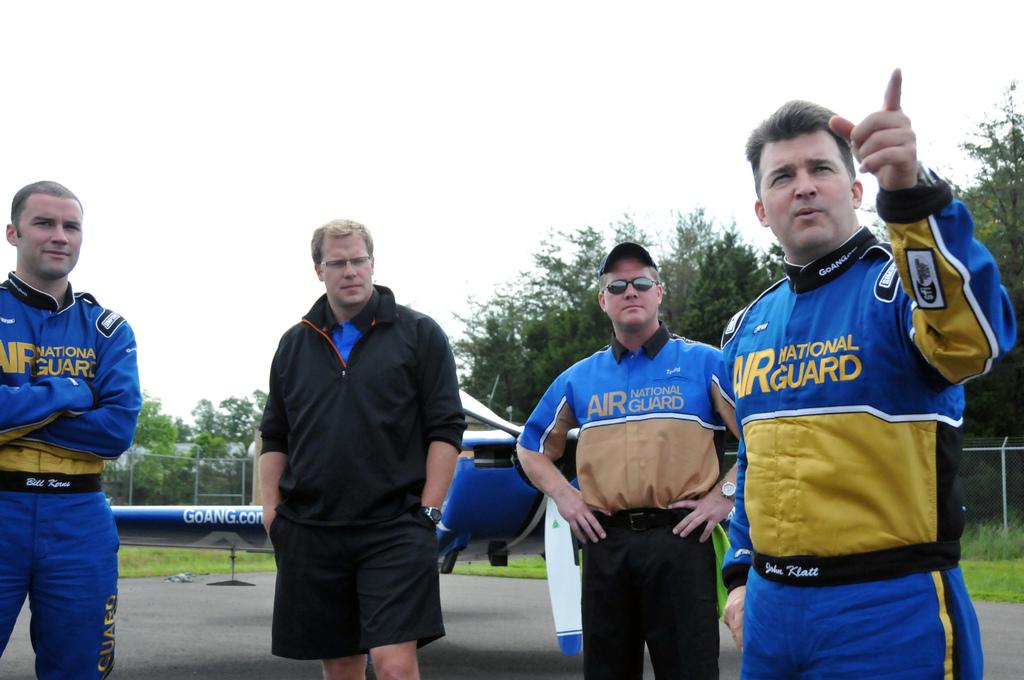What is written on the man's jersey on the right?
Offer a very short reply. National guard. What is the url on the airplane wing in the back?
Your answer should be compact. Goang.com. 